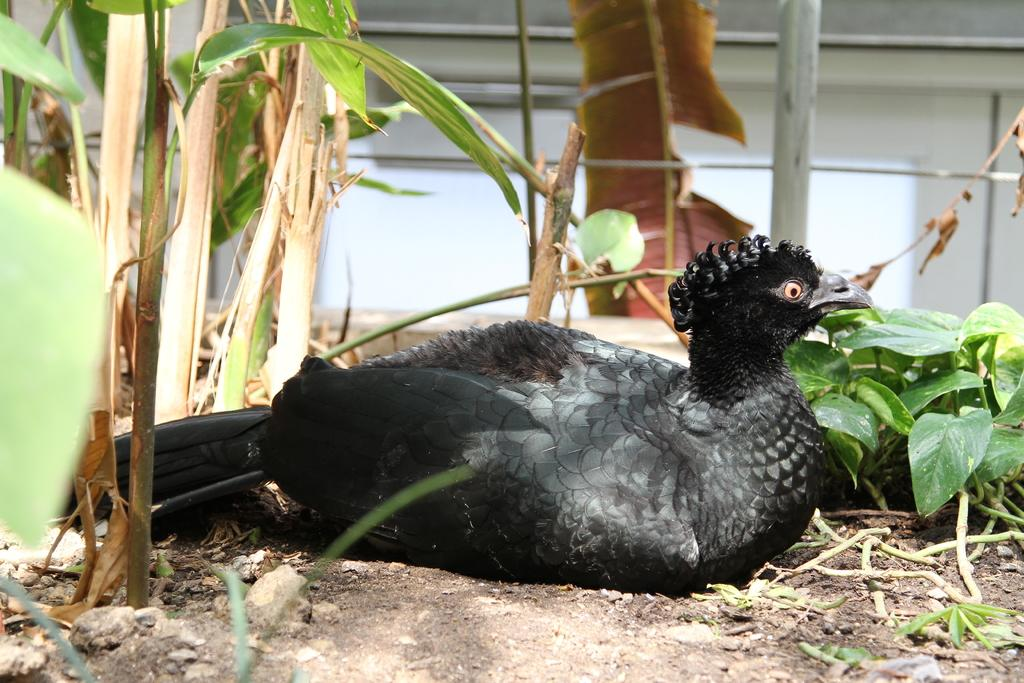What type of animal is in the image? There is a bird in the image. What color is the bird? The bird is black in color. What can be seen on the left side of the image? There are plants on the left side of the image. What type of button is the bird trying to reach in the image? There is no button present in the image, and the bird is not shown trying to reach anything. 